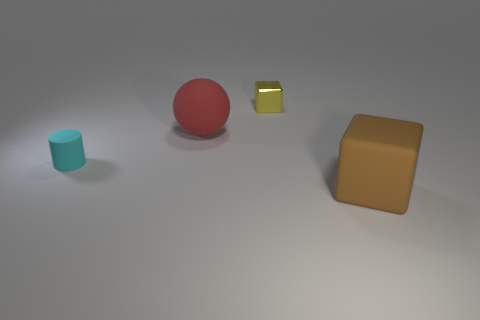Subtract all brown cubes. How many cubes are left? 1 Add 1 large brown blocks. How many objects exist? 5 Subtract 1 balls. How many balls are left? 0 Subtract all cyan blocks. Subtract all yellow balls. How many blocks are left? 2 Subtract all green balls. How many yellow cubes are left? 1 Subtract all big red balls. Subtract all tiny shiny objects. How many objects are left? 2 Add 3 small objects. How many small objects are left? 5 Add 2 purple matte objects. How many purple matte objects exist? 2 Subtract 0 purple cubes. How many objects are left? 4 Subtract all spheres. How many objects are left? 3 